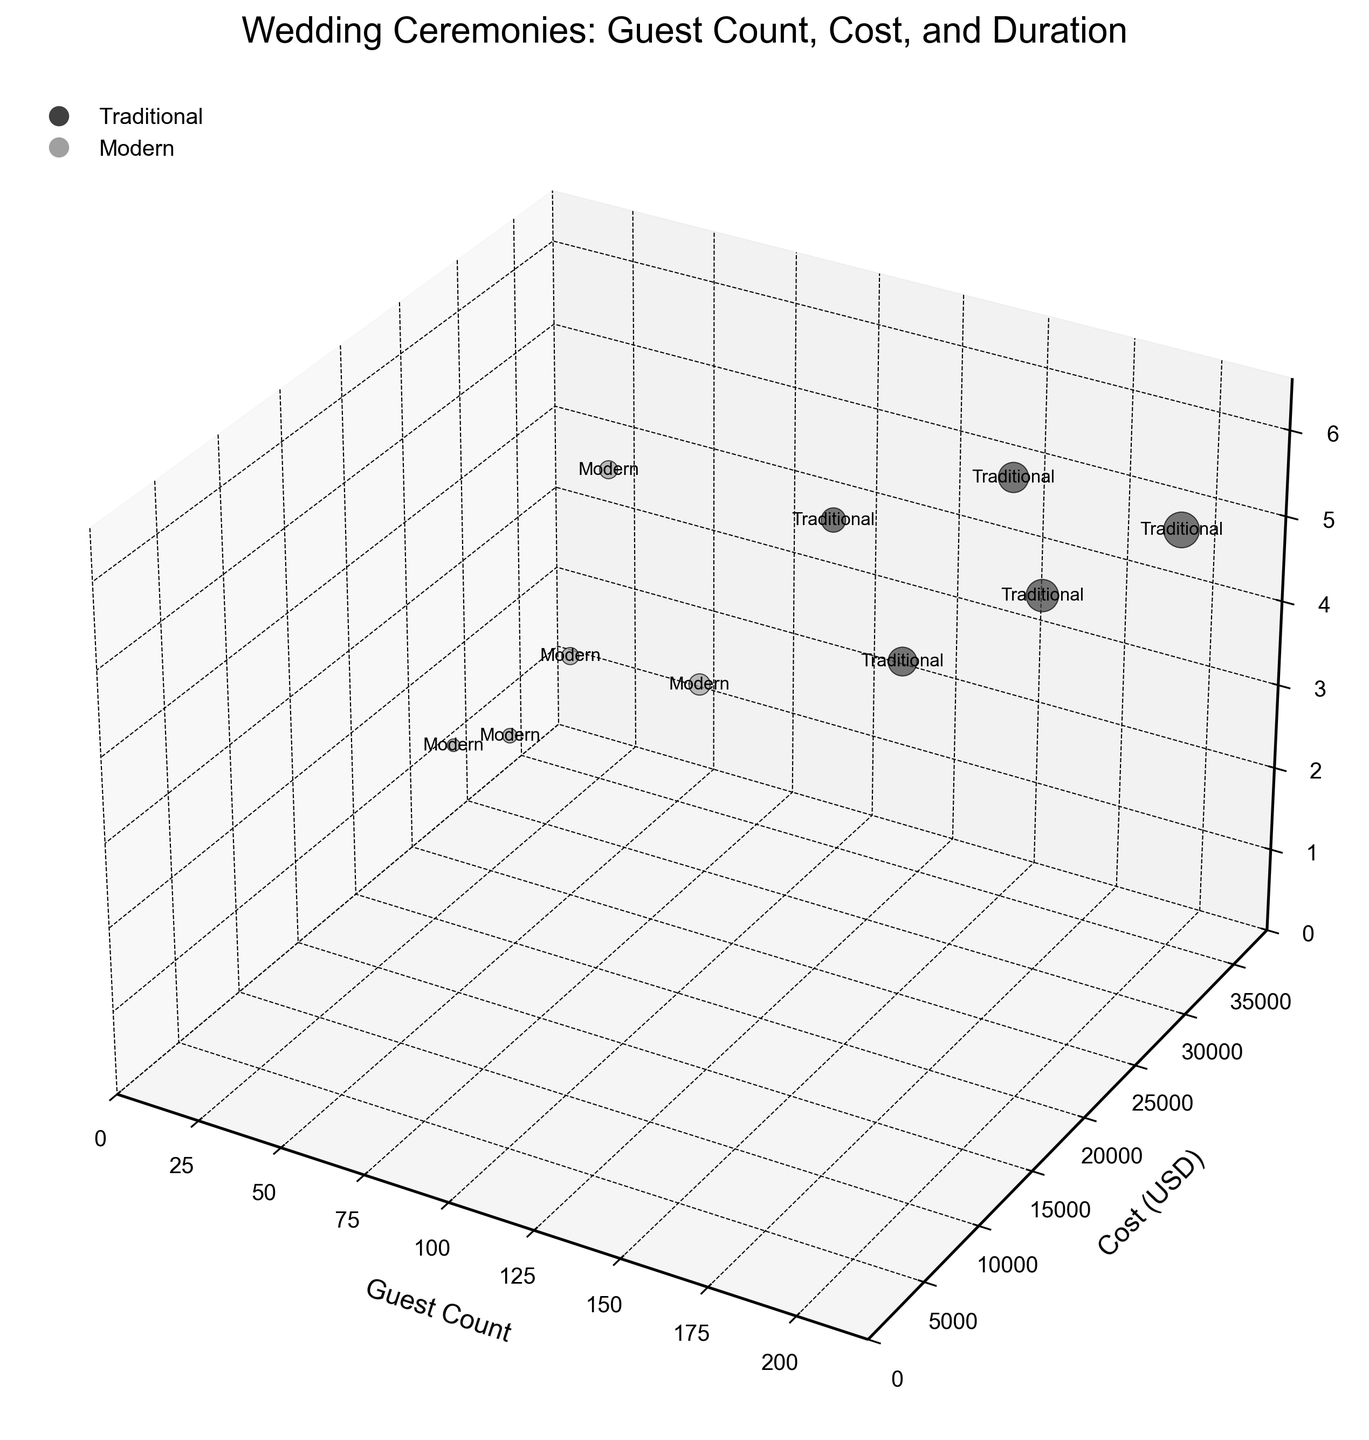How many ceremony types are depicted in the figure? The title indicates it compares traditional vs. modern wedding ceremonies with different characteristics. By counting the unique ceremony types listed in the data table, we find there are 10.
Answer: 10 What are the colors representing in the chart? Based on the data and figure description, colors differentiate between traditional and modern wedding ceremonies, with traditional in a darker shade of gray and modern in a lighter shade.
Answer: Traditional (darker gray), Modern (lighter gray) Which ceremony type has the smallest number of guests, and how many guests are there? Observing the 'Guest Count' axis and bubble sizes, the Modern Destination Wedding has the smallest number of guests, which is 50.
Answer: Modern Destination Wedding, 50 What's the most expensive wedding ceremony in terms of cost, and how much does it cost? Inspecting the 'Cost (USD)' axis, the Traditional Ballroom Reception has the highest expenditure of $35,000.
Answer: Traditional Ballroom Reception, $35,000 What is the average duration (hours) of traditional wedding ceremonies? To find this, sum the durations of all traditional ceremony types (4 + 5 + 4.5 + 5 + 5.5) and divide by the number of traditional types (5). Calculation: (4 + 5 + 4.5 + 5 + 5.5)/5 = 4.8 hours.
Answer: 4.8 hours Which ceremony type has the shortest duration, and how many hours is it? Observing the 'Duration (Hours)' axis, the Modern Destination Wedding and Modern Beach Ceremony have the shortest duration, both at 3 hours.
Answer: Modern Destination Wedding, Modern Beach Ceremony, 3 hours Compare the guest count between Traditional Estate Garden Wedding and Modern Rooftop City Wedding. Which one hosted more guests, and by how many? Traditional Estate Garden Wedding has 120 guests, while Modern Rooftop City Wedding has 100 guests, thus Traditional Estate hosted 20 more guests.
Answer: Traditional Estate Garden Wedding, 20 more guests What’s the total cost of all modern wedding ceremonies? By adding the costs of all modern ceremonies: 15000 (Destination) + 20000 (Rustic Barn) + 22000 (Rooftop City) + 18000 (Industrial Loft) + 17000 (Beach) = $92,000.
Answer: $92,000 Which type of wedding ceremony has the longest duration, and how many hours is it? Observing the 'Duration (Hours)' axis, the Modern Rustic Barn Wedding has the longest duration at 6 hours.
Answer: Modern Rustic Barn Wedding, 6 hours Considering both cost and guest count, which traditional wedding ceremony is the most cost-effective measured by cost per guest? Calculating cost per guest for each traditional ceremony and comparing:
- Church: 25000/150 = 166.67
- Ballroom: 35000/200 = 175
- Country Club: 30000/175 = 171.43
- Estate Garden: 28000/120 = 233.33
- Vineyard: 32000/160 = 200
Hence, Traditional Church Wedding is the most cost-effective.
Answer: Traditional Church Wedding, $166.67 per guest 